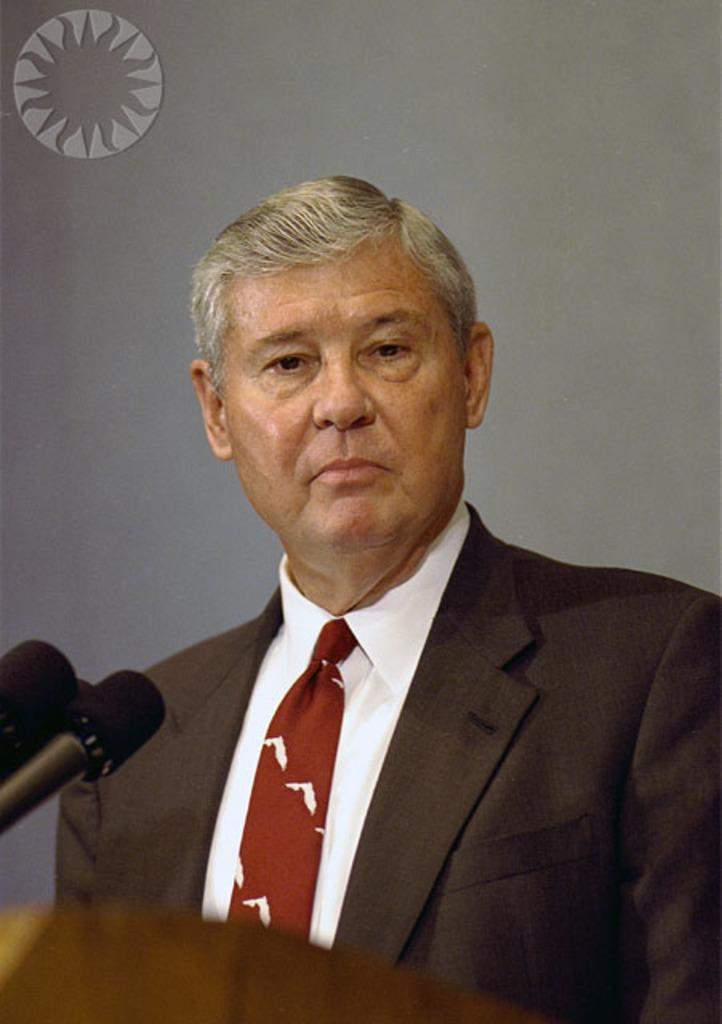What is the main subject of the image? There is a man standing in the center of the image. What is the man wearing? The man is wearing a suit. What objects are in front of the man? There are microphones (mics) in front of the man. What is located at the bottom of the image? There is a podium at the bottom of the image. What can be seen in the background of the image? There is a wall in the background of the image. What type of theory is the man presenting in the image? There is no indication in the image that the man is presenting a theory, as there are no visual cues or context to suggest this. --- 